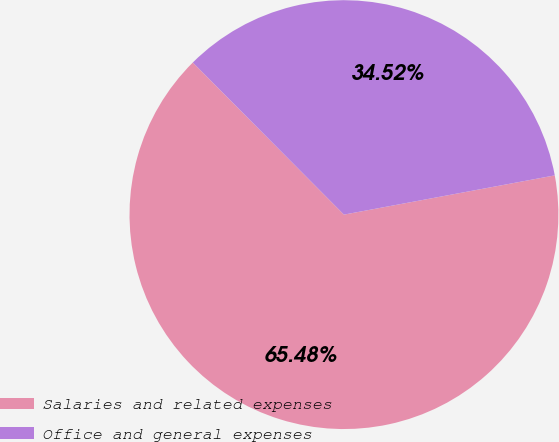<chart> <loc_0><loc_0><loc_500><loc_500><pie_chart><fcel>Salaries and related expenses<fcel>Office and general expenses<nl><fcel>65.48%<fcel>34.52%<nl></chart> 